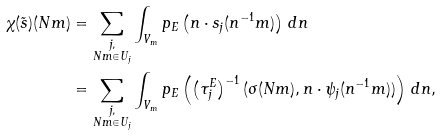<formula> <loc_0><loc_0><loc_500><loc_500>\chi ( \tilde { s } ) ( N m ) & = \sum _ { \substack { j , \\ N m \in U _ { j } } } \int _ { V _ { m } } p _ { E } \left ( n \cdot s _ { j } ( n ^ { - 1 } m ) \right ) \, d n \\ & = \sum _ { \substack { j , \\ N m \in U _ { j } } } \int _ { V _ { m } } p _ { E } \left ( \left ( \tau _ { j } ^ { E } \right ) ^ { - 1 } ( \sigma ( N m ) , n \cdot \psi _ { j } ( n ^ { - 1 } m ) ) \right ) \, d n ,</formula> 